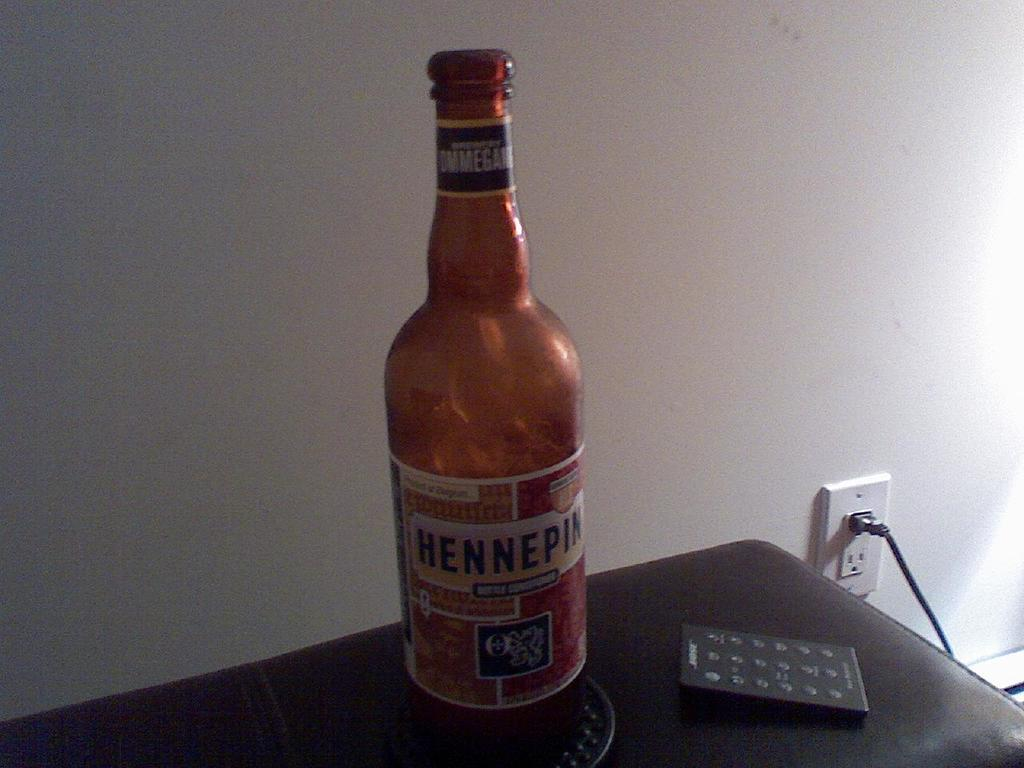<image>
Write a terse but informative summary of the picture. A bottle of Hennepin sits next to a remote. 